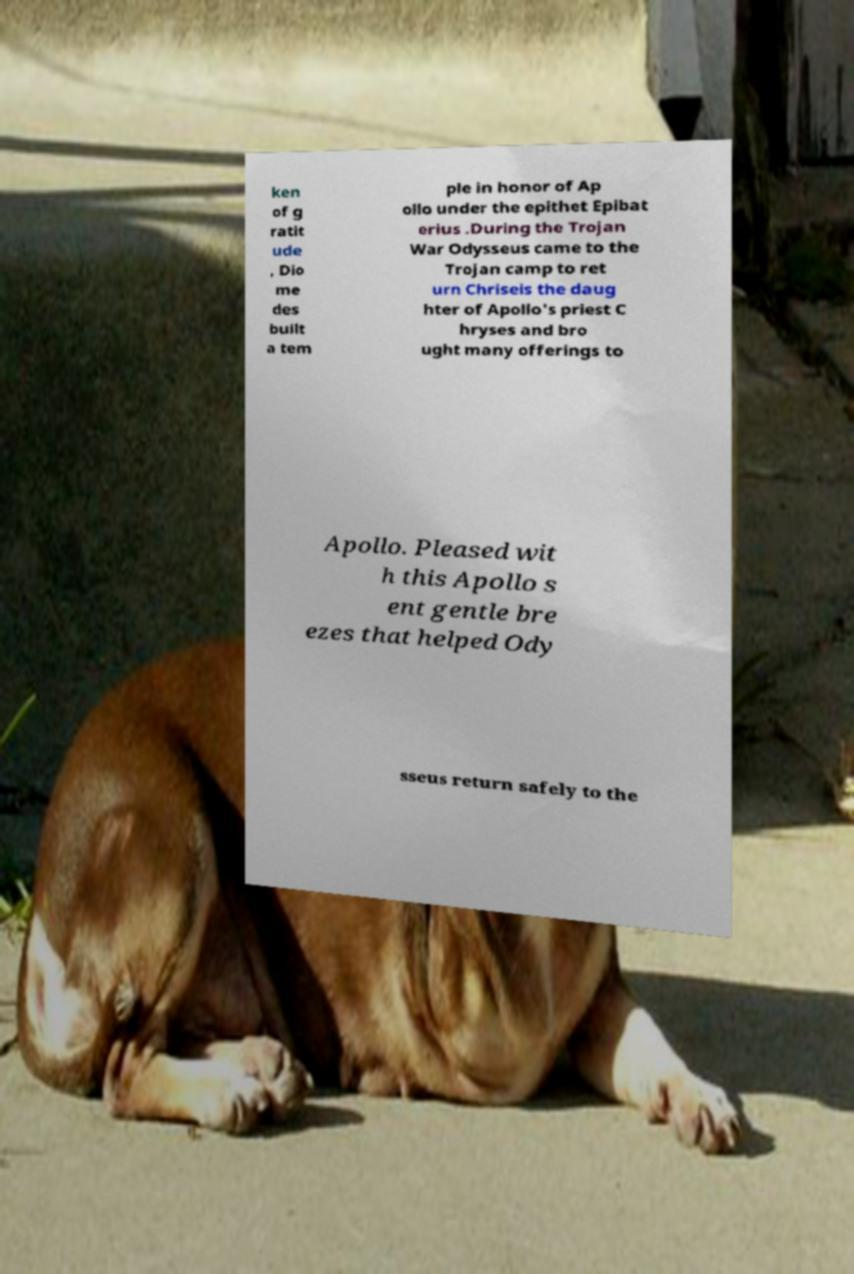There's text embedded in this image that I need extracted. Can you transcribe it verbatim? ken of g ratit ude , Dio me des built a tem ple in honor of Ap ollo under the epithet Epibat erius .During the Trojan War Odysseus came to the Trojan camp to ret urn Chriseis the daug hter of Apollo's priest C hryses and bro ught many offerings to Apollo. Pleased wit h this Apollo s ent gentle bre ezes that helped Ody sseus return safely to the 